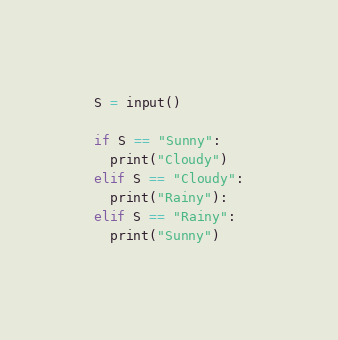<code> <loc_0><loc_0><loc_500><loc_500><_Python_>S = input()

if S == "Sunny":
  print("Cloudy")
elif S == "Cloudy":
  print("Rainy"):
elif S == "Rainy":
  print("Sunny")</code> 